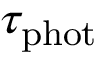<formula> <loc_0><loc_0><loc_500><loc_500>\tau _ { p h o t }</formula> 